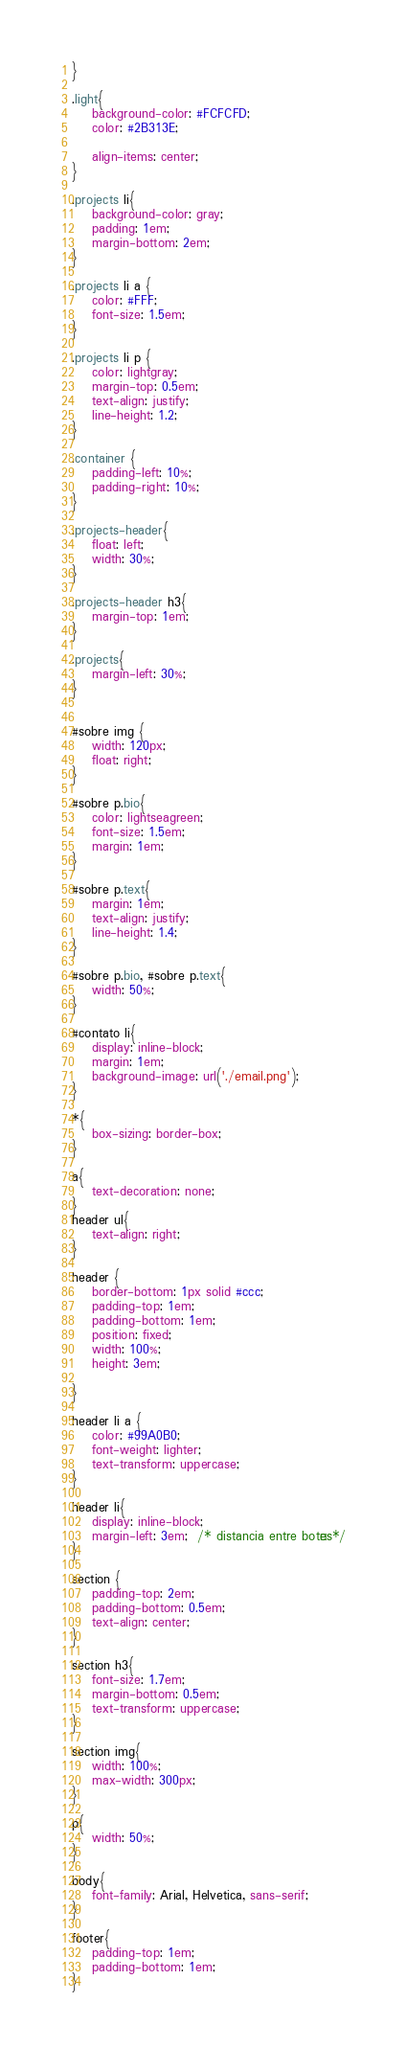Convert code to text. <code><loc_0><loc_0><loc_500><loc_500><_CSS_>}

.light{
    background-color: #FCFCFD;
    color: #2B313E;

    align-items: center;
}

.projects li{
    background-color: gray;
    padding: 1em;
    margin-bottom: 2em;
}

.projects li a {
    color: #FFF;
    font-size: 1.5em;
}

.projects li p {
    color: lightgray;
    margin-top: 0.5em;
    text-align: justify;
    line-height: 1.2;
}

.container {
    padding-left: 10%;
    padding-right: 10%;
}

.projects-header{
    float: left;
    width: 30%;
}

.projects-header h3{
    margin-top: 1em;
}

.projects{
    margin-left: 30%;
}


#sobre img {
    width: 120px;
    float: right;
}

#sobre p.bio{
    color: lightseagreen;
    font-size: 1.5em;
    margin: 1em;
}

#sobre p.text{
    margin: 1em;
    text-align: justify;
    line-height: 1.4;
}

#sobre p.bio, #sobre p.text{
    width: 50%;
}

#contato li{
    display: inline-block;
    margin: 1em;
    background-image: url('./email.png');
}

*{
    box-sizing: border-box;
}

a{
    text-decoration: none;
}
header ul{
    text-align: right;
}

header {
    border-bottom: 1px solid #ccc;
    padding-top: 1em;
    padding-bottom: 1em;
    position: fixed;
    width: 100%;
    height: 3em;
    
}

header li a {
    color: #99A0B0;
    font-weight: lighter;
    text-transform: uppercase;
}

header li{
    display: inline-block;
    margin-left: 3em;  /* distancia entre botões*/
}

section {
    padding-top: 2em;
    padding-bottom: 0.5em;
    text-align: center;
}

section h3{
    font-size: 1.7em;
    margin-bottom: 0.5em;
    text-transform: uppercase;
}

section img{
    width: 100%;
    max-width: 300px;
}

p{
    width: 50%;
}

body{
    font-family: Arial, Helvetica, sans-serif;
}

footer{
    padding-top: 1em;
    padding-bottom: 1em;
}

</code> 